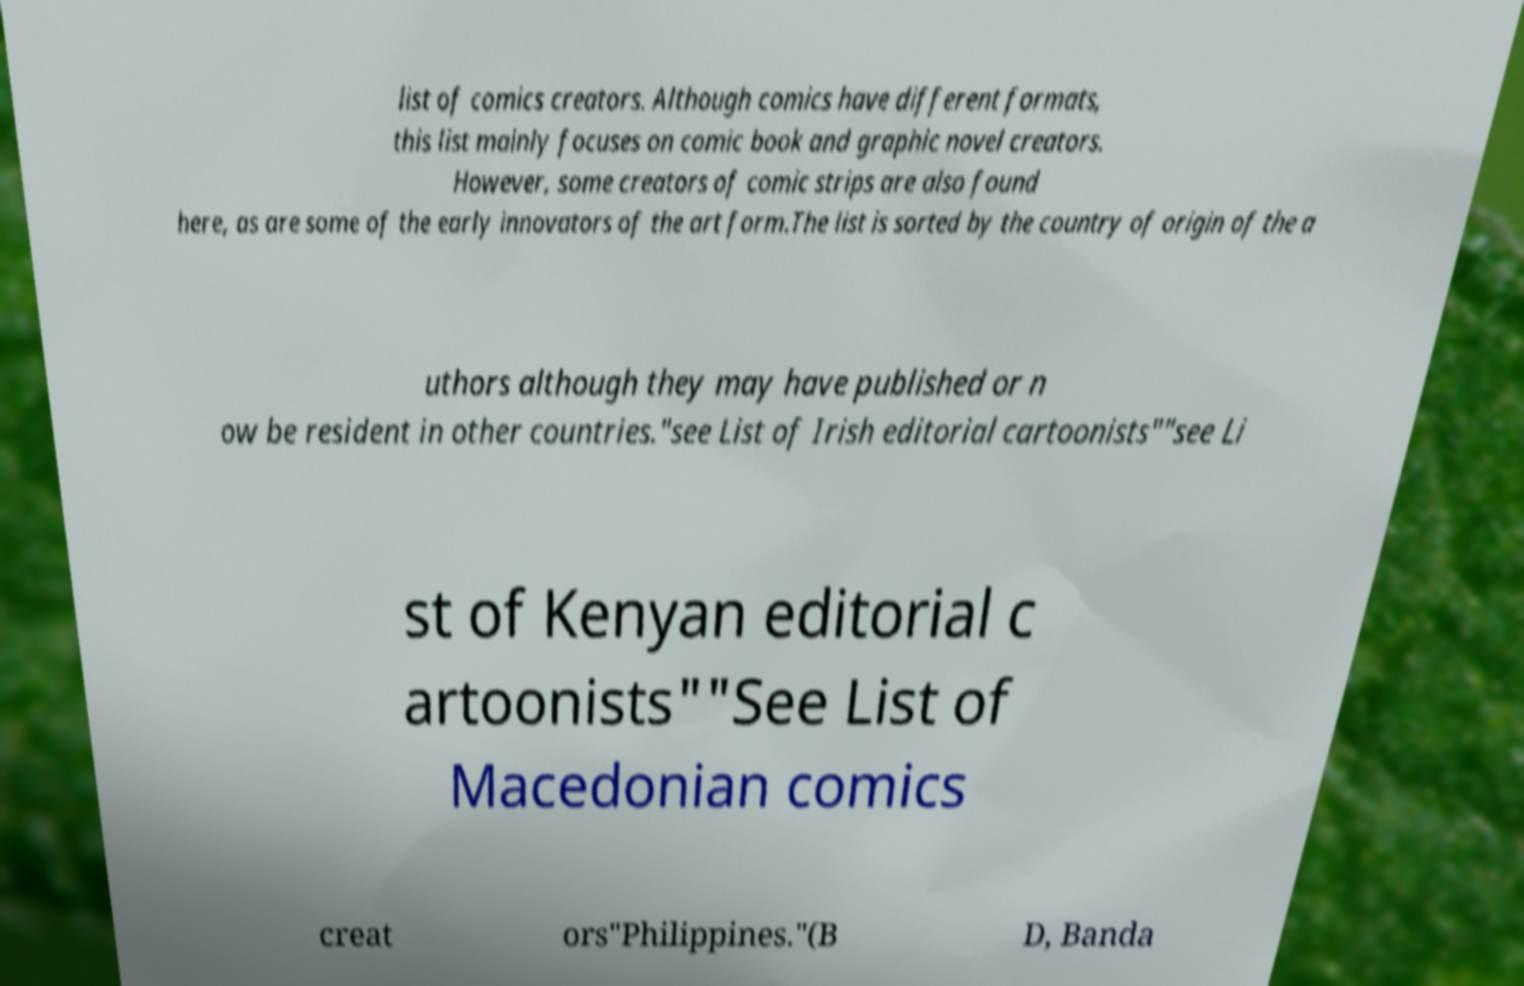For documentation purposes, I need the text within this image transcribed. Could you provide that? list of comics creators. Although comics have different formats, this list mainly focuses on comic book and graphic novel creators. However, some creators of comic strips are also found here, as are some of the early innovators of the art form.The list is sorted by the country of origin of the a uthors although they may have published or n ow be resident in other countries."see List of Irish editorial cartoonists""see Li st of Kenyan editorial c artoonists""See List of Macedonian comics creat ors"Philippines."(B D, Banda 